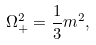<formula> <loc_0><loc_0><loc_500><loc_500>\Omega _ { + } ^ { 2 } = \frac { 1 } { 3 } m ^ { 2 } ,</formula> 